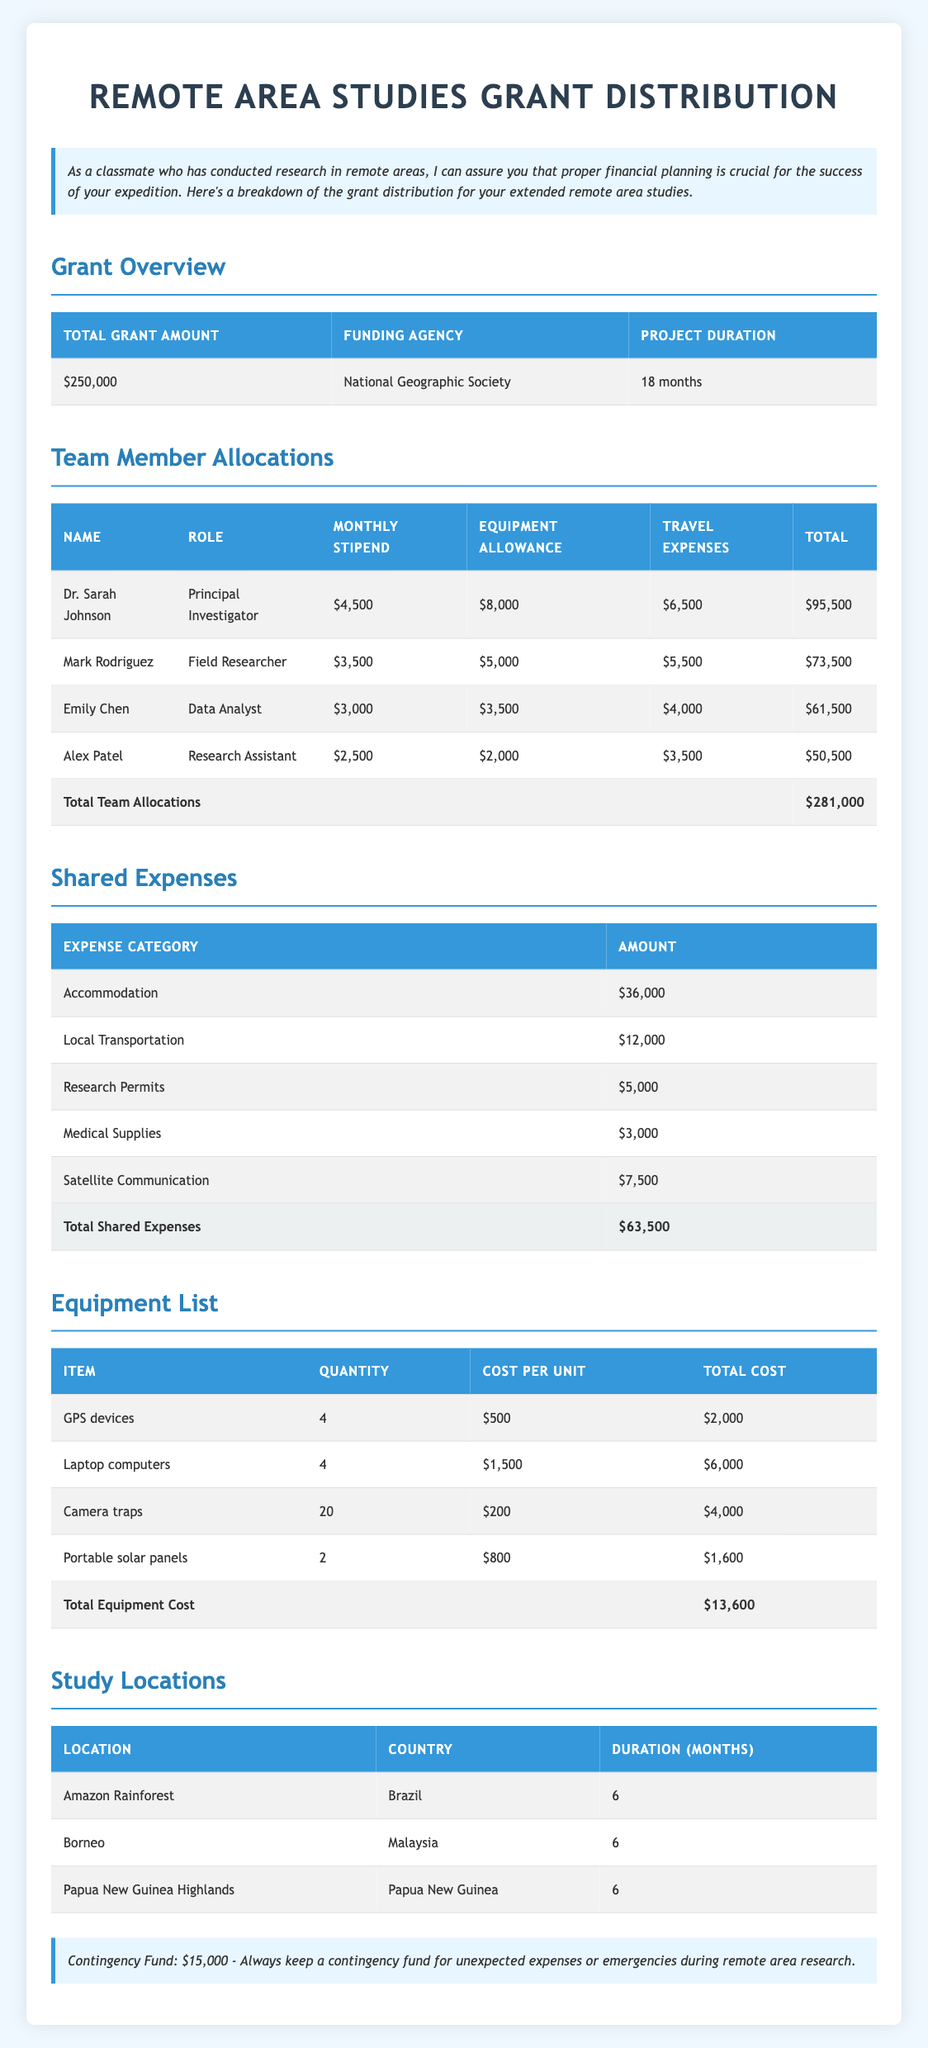What is the total grant amount for this project? The total grant amount is directly stated in the "Grant Overview" section of the table.
Answer: $250,000 What are the travel expenses allocated for Dr. Sarah Johnson? The travel expenses for Dr. Sarah Johnson are listed in the "Team Member Allocations" section under her respective row.
Answer: $6,500 What is the total stipend allocation for all team members over 18 months? To find the total stipend allocation, we first sum the monthly stipends for each member (4,500 + 3,500 + 3,000 + 2,500) which equals $13,500. Next, multiply that total by the project duration in months (18): 13,500 * 18 = $243,000.
Answer: $243,000 Is Mark Rodriguez's total allocation greater than that of Alex Patel's? The total allocation for Mark Rodriguez is $73,500, and for Alex Patel, it is $50,500. Since $73,500 is greater than $50,500, the statement is true.
Answer: Yes What is the total cost of the equipment needed for the project? The total equipment cost is found in the "Equipment List" section. Adding the total costs of each item (2,000 + 6,000 + 4,000 + 1,600) gives us $13,600.
Answer: $13,600 How much is spent on shared expenses for accommodation and local transportation combined? The amount for accommodation is $36,000 and for local transportation is $12,000. Summing these two amounts gives: 36,000 + 12,000 = 48,000.
Answer: $48,000 Is the contingency fund sufficient to cover any unexpected expenses exceeding $10,000? The contingency fund is $15,000, which is greater than $10,000. Therefore, it is sufficient.
Answer: Yes Which team member has the highest total allocation? By examining the total allocations for each member: Dr. Sarah Johnson has $95,500, Mark Rodriguez has $73,500, Emily Chen has $61,500, and Alex Patel has $50,500. Dr. Sarah Johnson has the highest total allocation of $95,500.
Answer: Dr. Sarah Johnson What percent of the total grant amount is allocated to shared expenses? Total shared expenses are $63,500. To calculate the percentage of the total grant amount allocated to shared expenses, we use the formula: (63,500 / 250,000) * 100, which equals 25.4%.
Answer: 25.4% 